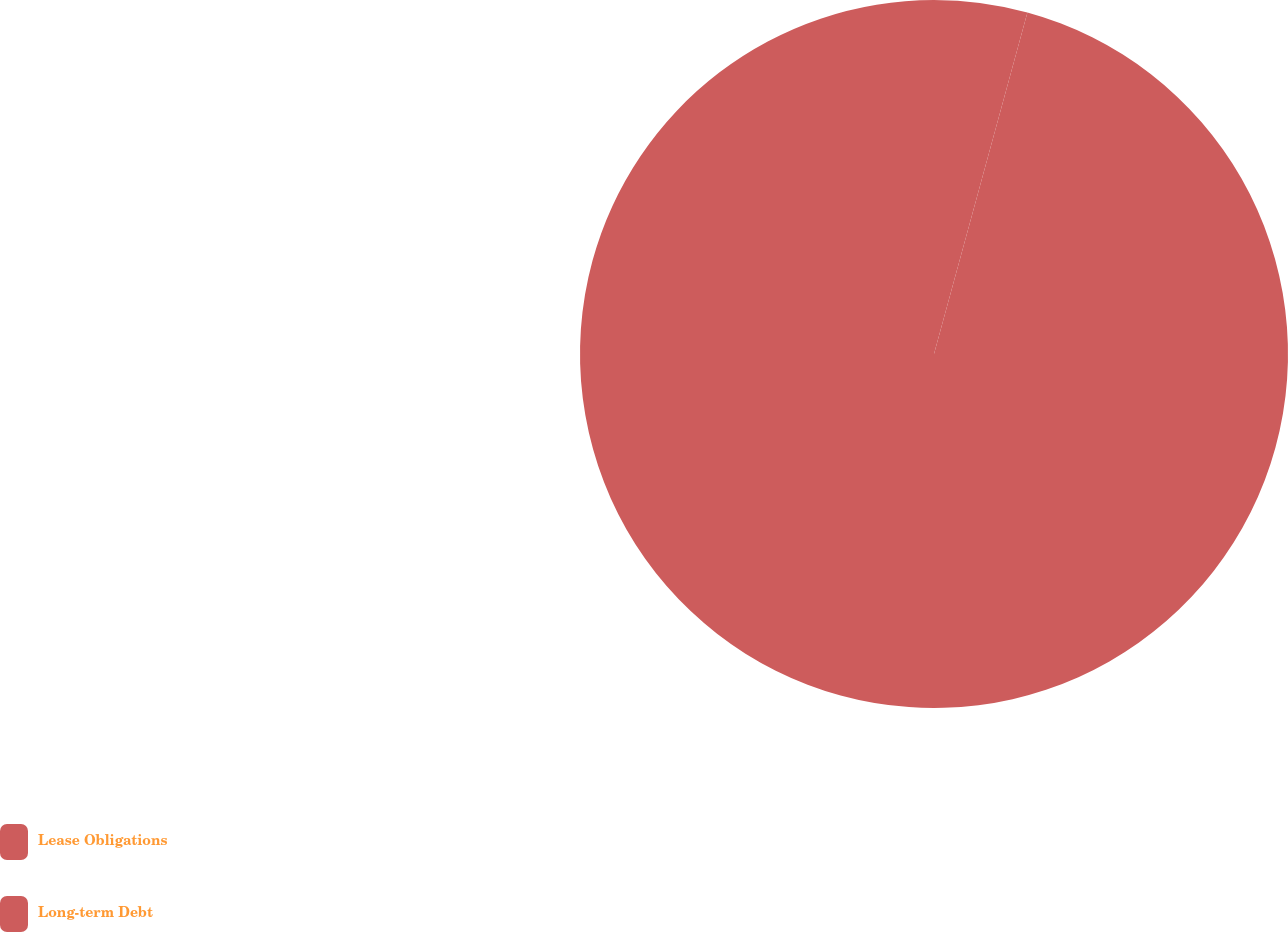Convert chart. <chart><loc_0><loc_0><loc_500><loc_500><pie_chart><fcel>Lease Obligations<fcel>Long-term Debt<nl><fcel>4.25%<fcel>95.75%<nl></chart> 